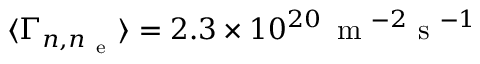Convert formula to latex. <formula><loc_0><loc_0><loc_500><loc_500>{ \langle \Gamma _ { n , n _ { e } } \rangle } = 2 . 3 \times 1 0 ^ { 2 0 } \, m ^ { - 2 } s ^ { - 1 }</formula> 